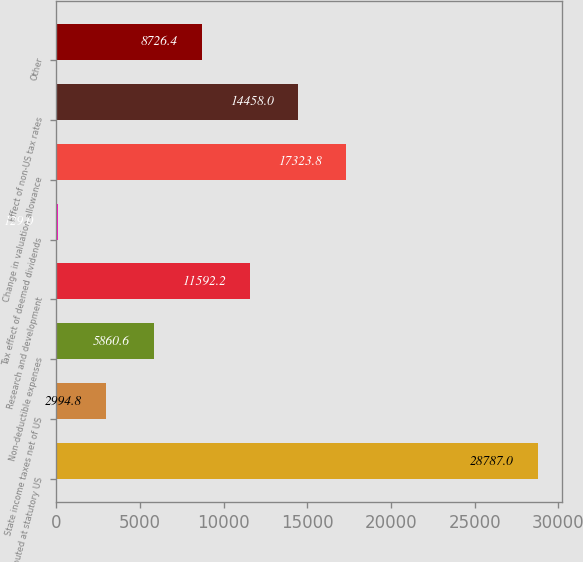Convert chart. <chart><loc_0><loc_0><loc_500><loc_500><bar_chart><fcel>Taxes computed at statutory US<fcel>State income taxes net of US<fcel>Non-deductible expenses<fcel>Research and development<fcel>Tax effect of deemed dividends<fcel>Change in valuation allowance<fcel>Effect of non-US tax rates<fcel>Other<nl><fcel>28787<fcel>2994.8<fcel>5860.6<fcel>11592.2<fcel>129<fcel>17323.8<fcel>14458<fcel>8726.4<nl></chart> 